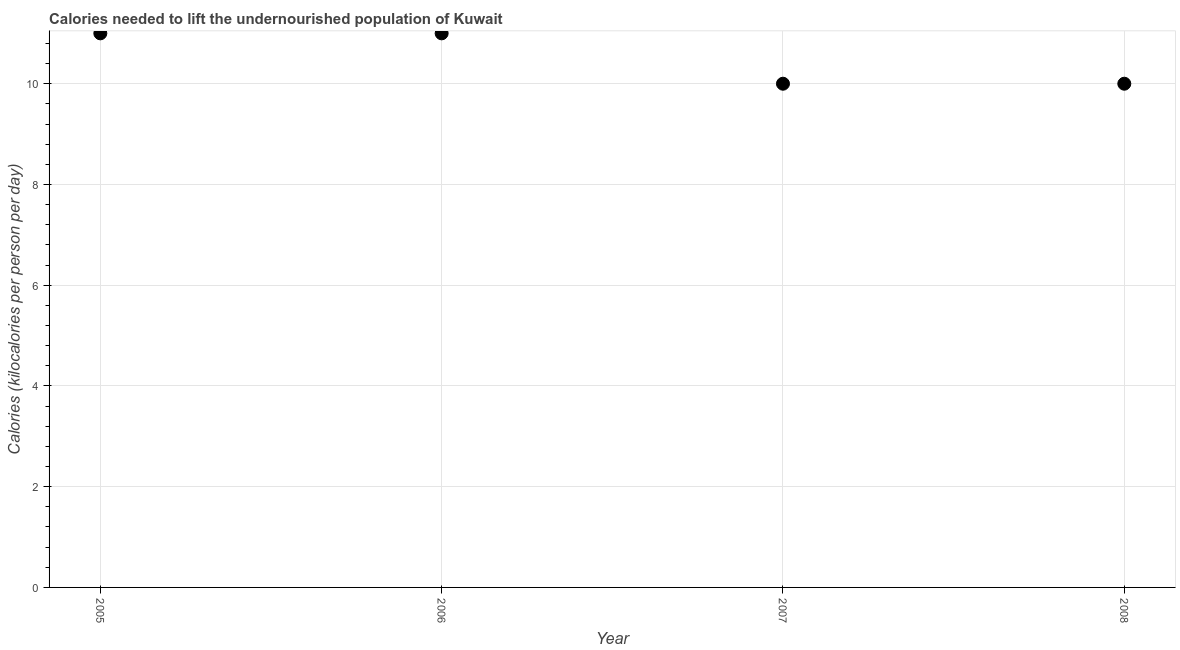What is the depth of food deficit in 2005?
Your response must be concise. 11. Across all years, what is the maximum depth of food deficit?
Your response must be concise. 11. Across all years, what is the minimum depth of food deficit?
Give a very brief answer. 10. In which year was the depth of food deficit maximum?
Your response must be concise. 2005. In which year was the depth of food deficit minimum?
Offer a very short reply. 2007. What is the sum of the depth of food deficit?
Your response must be concise. 42. What is the difference between the depth of food deficit in 2006 and 2008?
Ensure brevity in your answer.  1. What is the median depth of food deficit?
Keep it short and to the point. 10.5. In how many years, is the depth of food deficit greater than 2.4 kilocalories?
Your response must be concise. 4. Do a majority of the years between 2005 and 2008 (inclusive) have depth of food deficit greater than 4 kilocalories?
Offer a terse response. Yes. What is the ratio of the depth of food deficit in 2005 to that in 2006?
Offer a terse response. 1. Is the depth of food deficit in 2005 less than that in 2007?
Your response must be concise. No. What is the difference between the highest and the second highest depth of food deficit?
Your answer should be very brief. 0. What is the difference between the highest and the lowest depth of food deficit?
Give a very brief answer. 1. Does the depth of food deficit monotonically increase over the years?
Your response must be concise. No. How many dotlines are there?
Keep it short and to the point. 1. What is the difference between two consecutive major ticks on the Y-axis?
Provide a succinct answer. 2. Are the values on the major ticks of Y-axis written in scientific E-notation?
Ensure brevity in your answer.  No. Does the graph contain any zero values?
Provide a short and direct response. No. Does the graph contain grids?
Keep it short and to the point. Yes. What is the title of the graph?
Make the answer very short. Calories needed to lift the undernourished population of Kuwait. What is the label or title of the Y-axis?
Give a very brief answer. Calories (kilocalories per person per day). What is the Calories (kilocalories per person per day) in 2005?
Make the answer very short. 11. What is the Calories (kilocalories per person per day) in 2006?
Provide a succinct answer. 11. What is the difference between the Calories (kilocalories per person per day) in 2006 and 2007?
Keep it short and to the point. 1. What is the difference between the Calories (kilocalories per person per day) in 2006 and 2008?
Provide a short and direct response. 1. What is the difference between the Calories (kilocalories per person per day) in 2007 and 2008?
Your answer should be compact. 0. What is the ratio of the Calories (kilocalories per person per day) in 2005 to that in 2008?
Give a very brief answer. 1.1. What is the ratio of the Calories (kilocalories per person per day) in 2006 to that in 2008?
Provide a short and direct response. 1.1. 